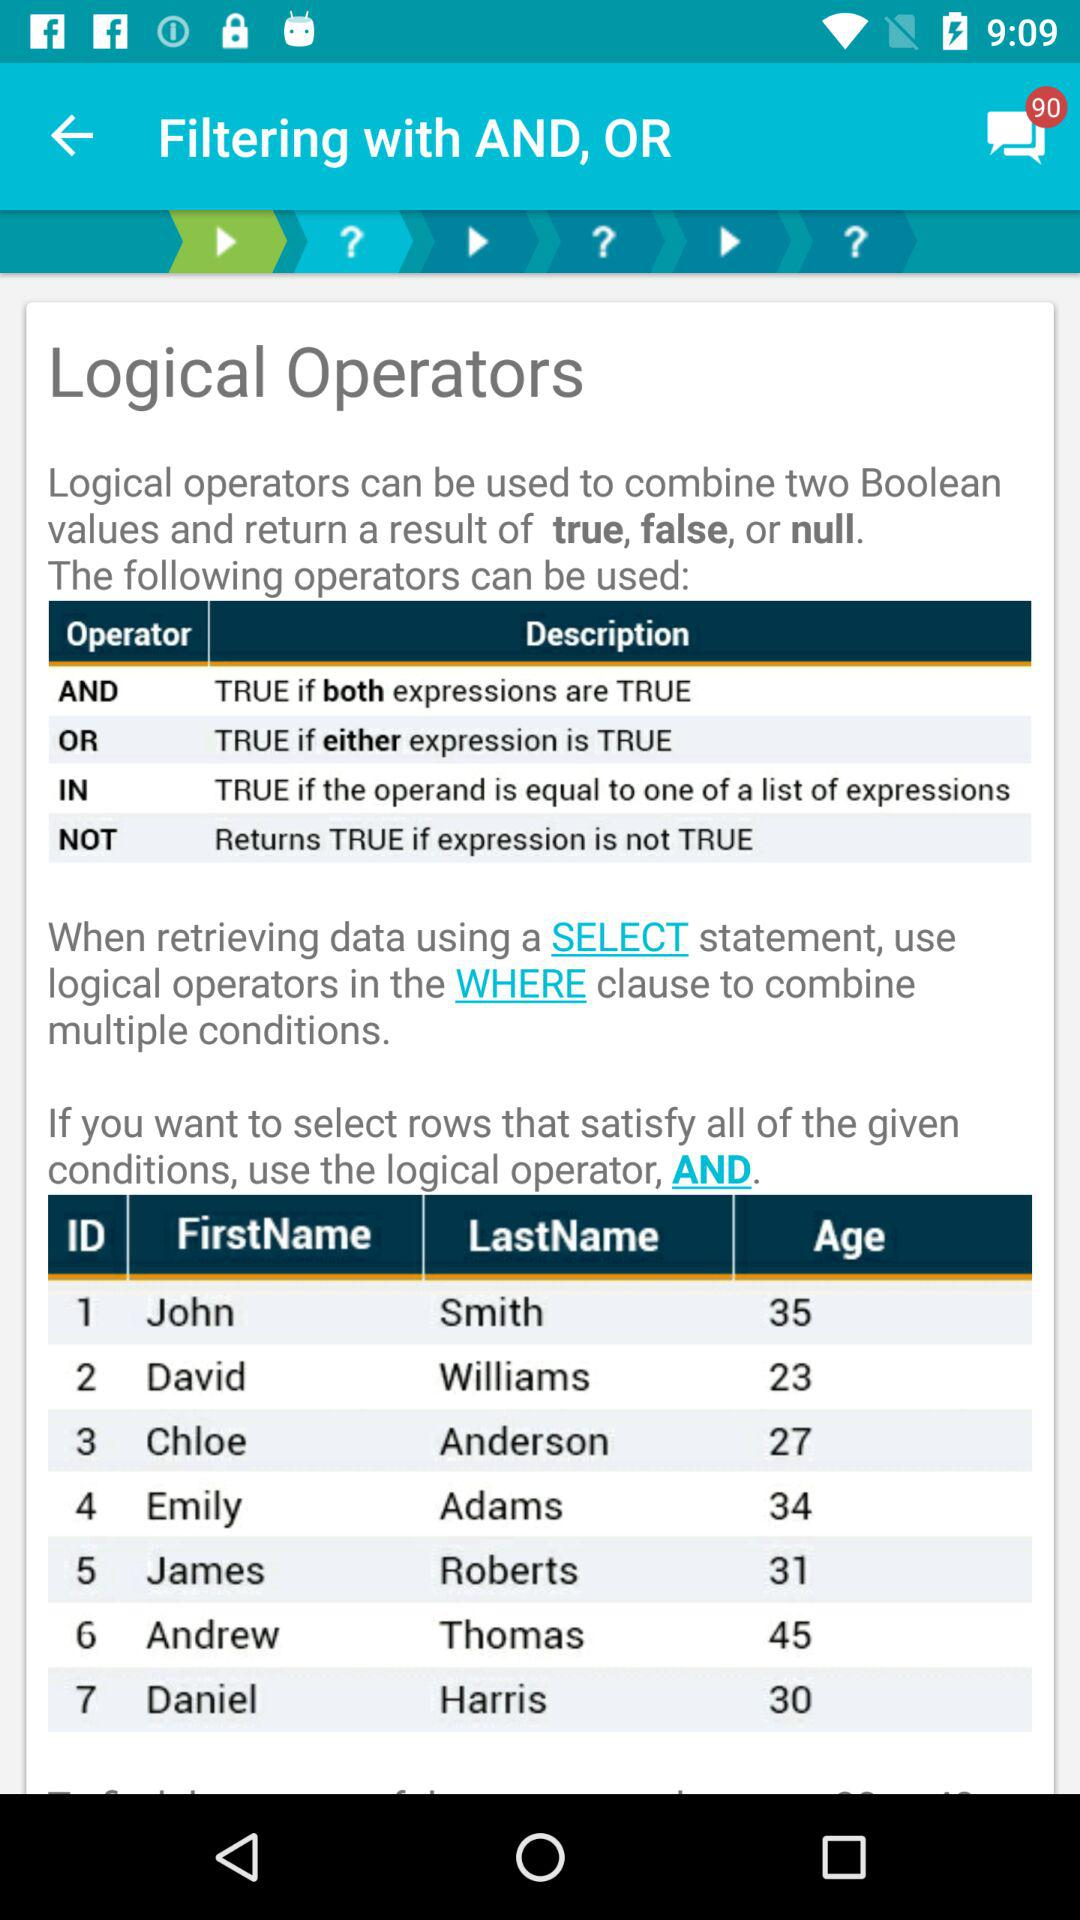What is the age of David Williams? David Williams is 23 years old. 